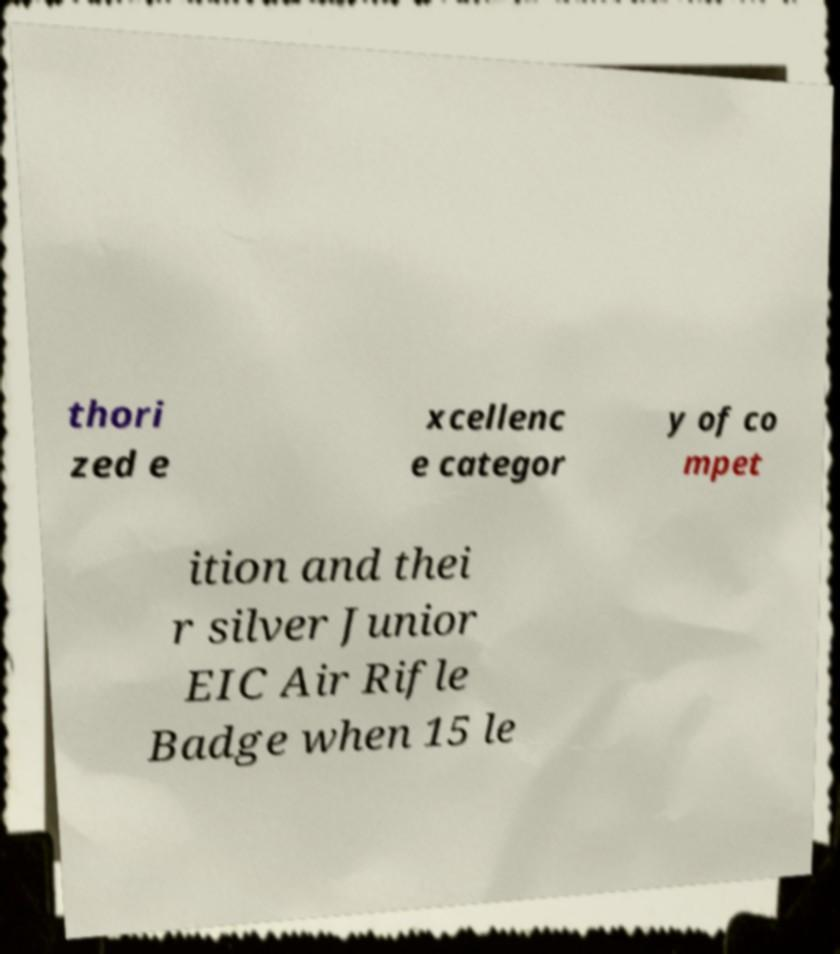I need the written content from this picture converted into text. Can you do that? thori zed e xcellenc e categor y of co mpet ition and thei r silver Junior EIC Air Rifle Badge when 15 le 